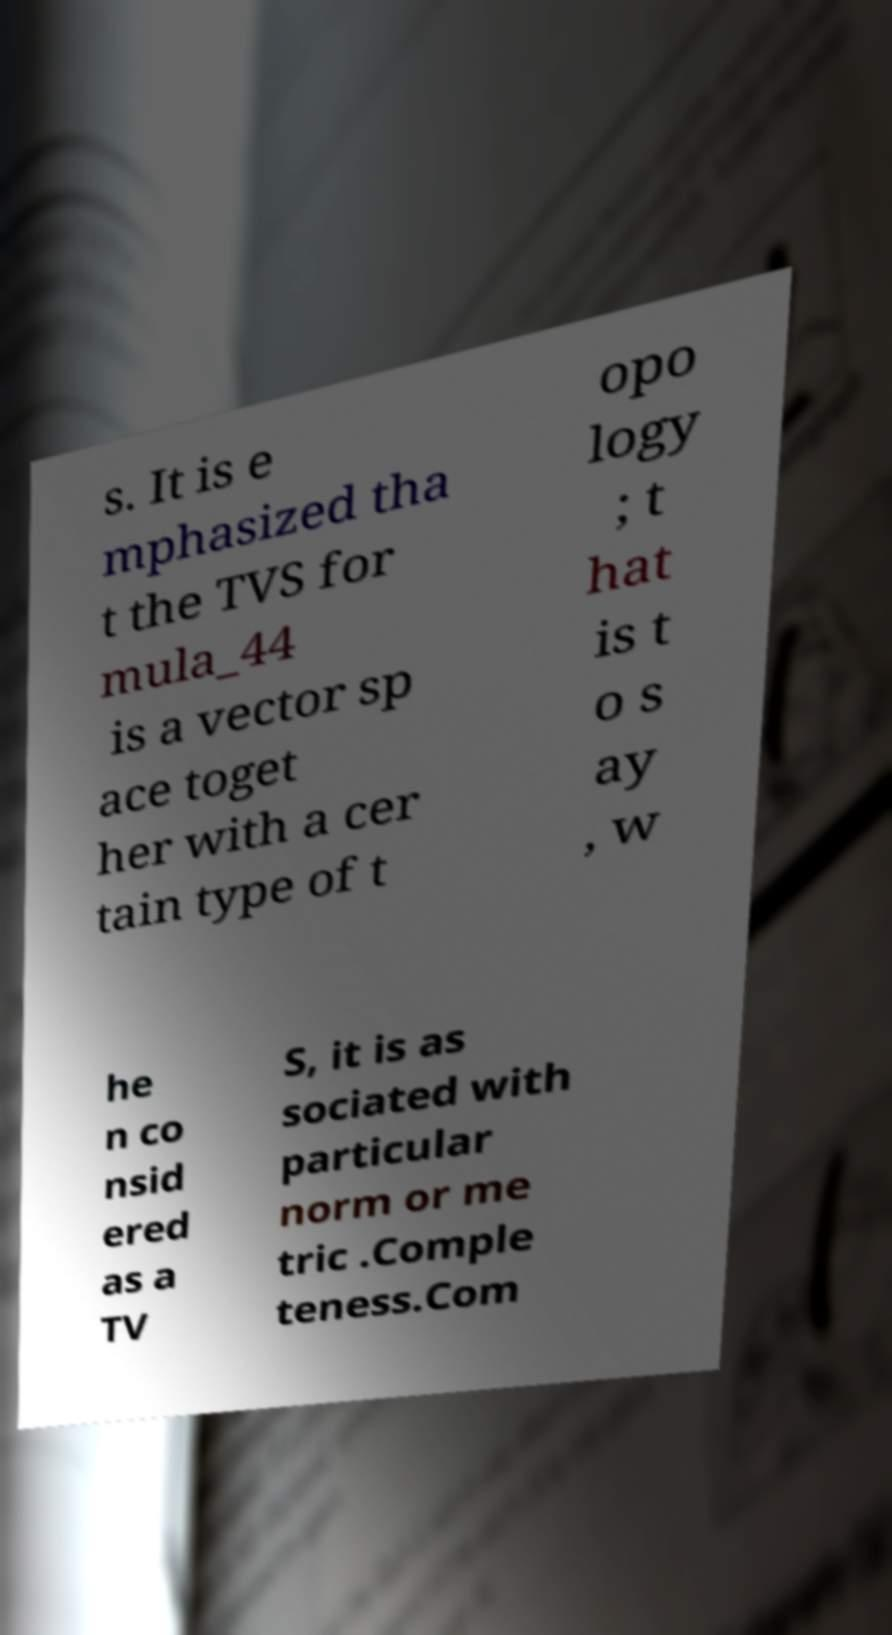I need the written content from this picture converted into text. Can you do that? s. It is e mphasized tha t the TVS for mula_44 is a vector sp ace toget her with a cer tain type of t opo logy ; t hat is t o s ay , w he n co nsid ered as a TV S, it is as sociated with particular norm or me tric .Comple teness.Com 